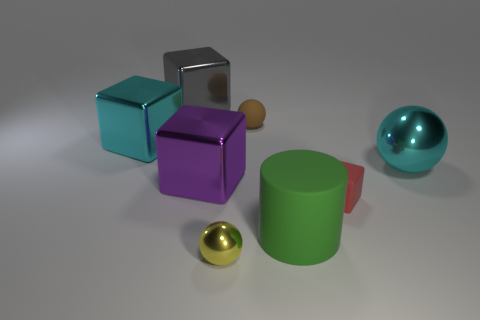There is a metallic ball right of the yellow sphere; is its size the same as the thing behind the tiny brown matte sphere?
Make the answer very short. Yes. What number of objects are either big green metallic cylinders or matte balls?
Offer a terse response. 1. There is a cyan shiny thing on the left side of the large gray metallic cube; what size is it?
Keep it short and to the point. Large. What number of big blocks are to the right of the tiny rubber thing in front of the big metallic ball that is on the right side of the large matte cylinder?
Ensure brevity in your answer.  0. Do the tiny cube and the matte sphere have the same color?
Offer a terse response. No. What number of matte things are both behind the green object and left of the red matte block?
Your answer should be compact. 1. The small matte object in front of the big cyan block has what shape?
Your answer should be very brief. Cube. Is the number of purple shiny things to the right of the red matte block less than the number of large green rubber objects that are to the left of the large purple thing?
Give a very brief answer. No. Does the tiny sphere that is in front of the large rubber object have the same material as the tiny ball that is behind the tiny yellow shiny ball?
Your answer should be very brief. No. The large matte thing has what shape?
Provide a succinct answer. Cylinder. 